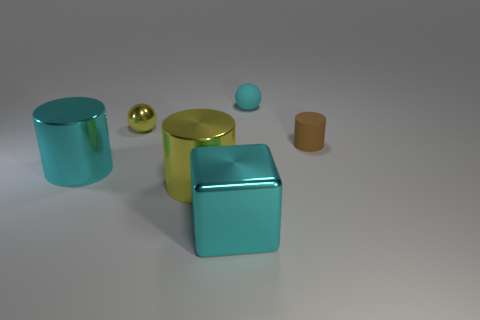Subtract all tiny rubber cylinders. How many cylinders are left? 2 Add 1 balls. How many objects exist? 7 Subtract all cubes. How many objects are left? 5 Subtract all yellow spheres. How many spheres are left? 1 Subtract all brown cylinders. Subtract all cyan balls. How many cylinders are left? 2 Subtract all green cubes. How many blue spheres are left? 0 Subtract all small red cylinders. Subtract all big cyan metallic things. How many objects are left? 4 Add 2 small brown rubber cylinders. How many small brown rubber cylinders are left? 3 Add 6 big metallic objects. How many big metallic objects exist? 9 Subtract 0 red cylinders. How many objects are left? 6 